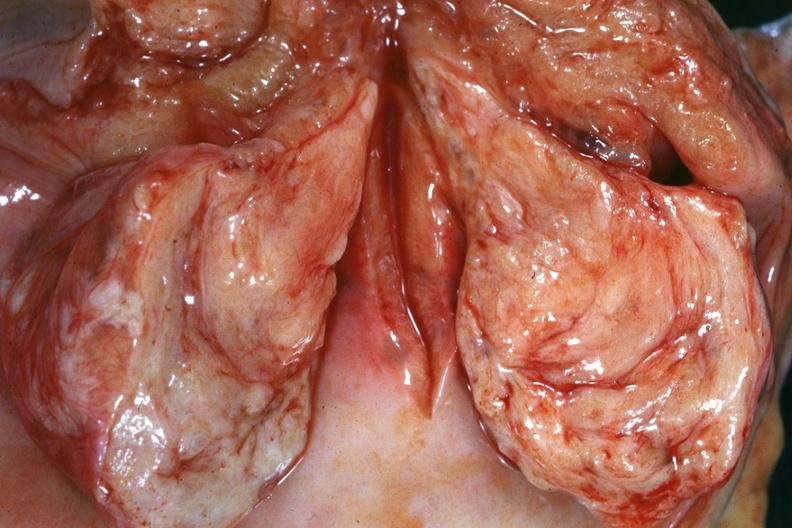where does this belong to?
Answer the question using a single word or phrase. Female reproductive system 